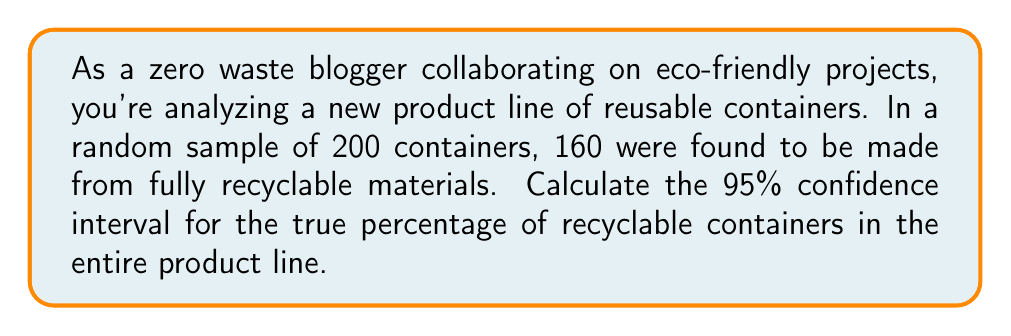Provide a solution to this math problem. Let's approach this step-by-step:

1) First, we need to calculate the sample proportion:
   $\hat{p} = \frac{\text{number of successes}}{\text{sample size}} = \frac{160}{200} = 0.8$ or 80%

2) The formula for the confidence interval is:
   $$\hat{p} \pm z_{\alpha/2} \sqrt{\frac{\hat{p}(1-\hat{p})}{n}}$$
   where:
   - $\hat{p}$ is the sample proportion
   - $z_{\alpha/2}$ is the critical value (1.96 for 95% confidence)
   - $n$ is the sample size

3) Let's substitute our values:
   $\hat{p} = 0.8$
   $z_{\alpha/2} = 1.96$
   $n = 200$

4) Calculate the standard error:
   $$\sqrt{\frac{\hat{p}(1-\hat{p})}{n}} = \sqrt{\frac{0.8(1-0.8)}{200}} = \sqrt{\frac{0.16}{200}} = 0.0283$$

5) Now, let's calculate the margin of error:
   $$1.96 \times 0.0283 = 0.0555$$

6) Finally, we can calculate the confidence interval:
   Lower bound: $0.8 - 0.0555 = 0.7445$ or 74.45%
   Upper bound: $0.8 + 0.0555 = 0.8555$ or 85.55%

Therefore, we can be 95% confident that the true percentage of recyclable containers in the entire product line is between 74.45% and 85.55%.
Answer: (74.45%, 85.55%) 